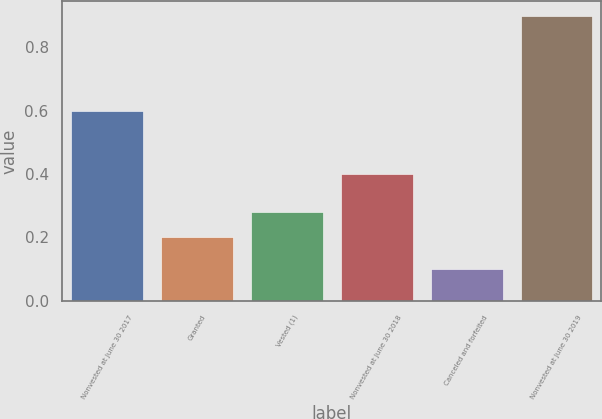Convert chart. <chart><loc_0><loc_0><loc_500><loc_500><bar_chart><fcel>Nonvested at June 30 2017<fcel>Granted<fcel>Vested (1)<fcel>Nonvested at June 30 2018<fcel>Canceled and forfeited<fcel>Nonvested at June 30 2019<nl><fcel>0.6<fcel>0.2<fcel>0.28<fcel>0.4<fcel>0.1<fcel>0.9<nl></chart> 